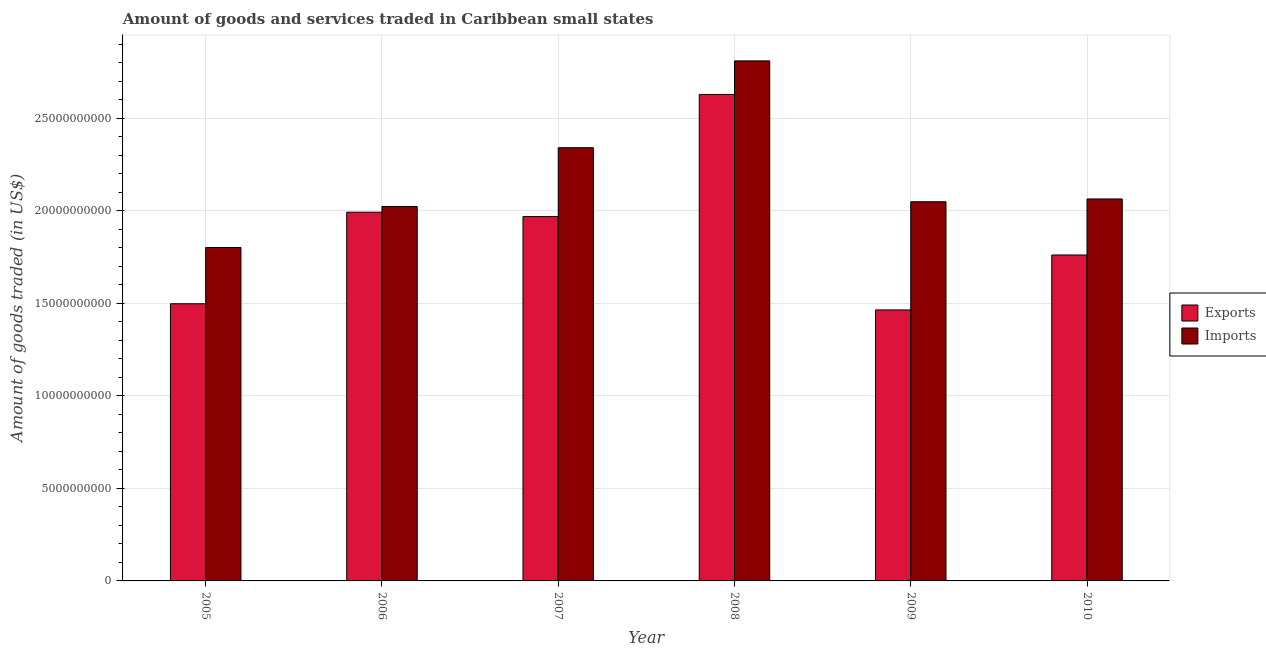How many different coloured bars are there?
Offer a terse response. 2. How many groups of bars are there?
Keep it short and to the point. 6. Are the number of bars per tick equal to the number of legend labels?
Make the answer very short. Yes. How many bars are there on the 4th tick from the left?
Offer a terse response. 2. How many bars are there on the 2nd tick from the right?
Give a very brief answer. 2. What is the label of the 1st group of bars from the left?
Ensure brevity in your answer.  2005. What is the amount of goods imported in 2005?
Your answer should be very brief. 1.80e+1. Across all years, what is the maximum amount of goods imported?
Give a very brief answer. 2.81e+1. Across all years, what is the minimum amount of goods imported?
Your answer should be compact. 1.80e+1. In which year was the amount of goods exported minimum?
Provide a succinct answer. 2009. What is the total amount of goods exported in the graph?
Your answer should be very brief. 1.13e+11. What is the difference between the amount of goods exported in 2009 and that in 2010?
Ensure brevity in your answer.  -2.97e+09. What is the difference between the amount of goods imported in 2005 and the amount of goods exported in 2006?
Keep it short and to the point. -2.21e+09. What is the average amount of goods exported per year?
Provide a succinct answer. 1.89e+1. What is the ratio of the amount of goods imported in 2006 to that in 2007?
Give a very brief answer. 0.86. What is the difference between the highest and the second highest amount of goods imported?
Make the answer very short. 4.69e+09. What is the difference between the highest and the lowest amount of goods exported?
Your answer should be very brief. 1.16e+1. What does the 2nd bar from the left in 2009 represents?
Offer a terse response. Imports. What does the 2nd bar from the right in 2007 represents?
Give a very brief answer. Exports. Are all the bars in the graph horizontal?
Provide a succinct answer. No. How many years are there in the graph?
Give a very brief answer. 6. What is the difference between two consecutive major ticks on the Y-axis?
Provide a succinct answer. 5.00e+09. Does the graph contain any zero values?
Provide a short and direct response. No. Where does the legend appear in the graph?
Your response must be concise. Center right. How many legend labels are there?
Provide a succinct answer. 2. How are the legend labels stacked?
Give a very brief answer. Vertical. What is the title of the graph?
Ensure brevity in your answer.  Amount of goods and services traded in Caribbean small states. What is the label or title of the Y-axis?
Provide a short and direct response. Amount of goods traded (in US$). What is the Amount of goods traded (in US$) in Exports in 2005?
Give a very brief answer. 1.50e+1. What is the Amount of goods traded (in US$) of Imports in 2005?
Offer a very short reply. 1.80e+1. What is the Amount of goods traded (in US$) of Exports in 2006?
Offer a very short reply. 1.99e+1. What is the Amount of goods traded (in US$) in Imports in 2006?
Offer a very short reply. 2.02e+1. What is the Amount of goods traded (in US$) in Exports in 2007?
Provide a short and direct response. 1.97e+1. What is the Amount of goods traded (in US$) of Imports in 2007?
Offer a very short reply. 2.34e+1. What is the Amount of goods traded (in US$) of Exports in 2008?
Keep it short and to the point. 2.63e+1. What is the Amount of goods traded (in US$) of Imports in 2008?
Give a very brief answer. 2.81e+1. What is the Amount of goods traded (in US$) in Exports in 2009?
Ensure brevity in your answer.  1.46e+1. What is the Amount of goods traded (in US$) of Imports in 2009?
Provide a short and direct response. 2.05e+1. What is the Amount of goods traded (in US$) in Exports in 2010?
Your answer should be compact. 1.76e+1. What is the Amount of goods traded (in US$) in Imports in 2010?
Provide a short and direct response. 2.06e+1. Across all years, what is the maximum Amount of goods traded (in US$) in Exports?
Provide a short and direct response. 2.63e+1. Across all years, what is the maximum Amount of goods traded (in US$) in Imports?
Give a very brief answer. 2.81e+1. Across all years, what is the minimum Amount of goods traded (in US$) in Exports?
Your response must be concise. 1.46e+1. Across all years, what is the minimum Amount of goods traded (in US$) in Imports?
Ensure brevity in your answer.  1.80e+1. What is the total Amount of goods traded (in US$) of Exports in the graph?
Provide a succinct answer. 1.13e+11. What is the total Amount of goods traded (in US$) of Imports in the graph?
Your response must be concise. 1.31e+11. What is the difference between the Amount of goods traded (in US$) of Exports in 2005 and that in 2006?
Your answer should be very brief. -4.95e+09. What is the difference between the Amount of goods traded (in US$) in Imports in 2005 and that in 2006?
Your answer should be very brief. -2.21e+09. What is the difference between the Amount of goods traded (in US$) of Exports in 2005 and that in 2007?
Keep it short and to the point. -4.71e+09. What is the difference between the Amount of goods traded (in US$) in Imports in 2005 and that in 2007?
Make the answer very short. -5.39e+09. What is the difference between the Amount of goods traded (in US$) in Exports in 2005 and that in 2008?
Offer a very short reply. -1.13e+1. What is the difference between the Amount of goods traded (in US$) in Imports in 2005 and that in 2008?
Make the answer very short. -1.01e+1. What is the difference between the Amount of goods traded (in US$) in Exports in 2005 and that in 2009?
Your answer should be very brief. 3.34e+08. What is the difference between the Amount of goods traded (in US$) of Imports in 2005 and that in 2009?
Make the answer very short. -2.47e+09. What is the difference between the Amount of goods traded (in US$) of Exports in 2005 and that in 2010?
Your answer should be compact. -2.63e+09. What is the difference between the Amount of goods traded (in US$) in Imports in 2005 and that in 2010?
Offer a very short reply. -2.62e+09. What is the difference between the Amount of goods traded (in US$) of Exports in 2006 and that in 2007?
Your answer should be compact. 2.35e+08. What is the difference between the Amount of goods traded (in US$) of Imports in 2006 and that in 2007?
Keep it short and to the point. -3.18e+09. What is the difference between the Amount of goods traded (in US$) of Exports in 2006 and that in 2008?
Make the answer very short. -6.36e+09. What is the difference between the Amount of goods traded (in US$) in Imports in 2006 and that in 2008?
Your answer should be compact. -7.87e+09. What is the difference between the Amount of goods traded (in US$) of Exports in 2006 and that in 2009?
Your answer should be very brief. 5.28e+09. What is the difference between the Amount of goods traded (in US$) of Imports in 2006 and that in 2009?
Give a very brief answer. -2.59e+08. What is the difference between the Amount of goods traded (in US$) of Exports in 2006 and that in 2010?
Provide a succinct answer. 2.31e+09. What is the difference between the Amount of goods traded (in US$) in Imports in 2006 and that in 2010?
Your answer should be very brief. -4.09e+08. What is the difference between the Amount of goods traded (in US$) of Exports in 2007 and that in 2008?
Offer a very short reply. -6.60e+09. What is the difference between the Amount of goods traded (in US$) of Imports in 2007 and that in 2008?
Your answer should be very brief. -4.69e+09. What is the difference between the Amount of goods traded (in US$) of Exports in 2007 and that in 2009?
Ensure brevity in your answer.  5.05e+09. What is the difference between the Amount of goods traded (in US$) in Imports in 2007 and that in 2009?
Provide a short and direct response. 2.92e+09. What is the difference between the Amount of goods traded (in US$) in Exports in 2007 and that in 2010?
Your answer should be compact. 2.08e+09. What is the difference between the Amount of goods traded (in US$) in Imports in 2007 and that in 2010?
Your answer should be very brief. 2.77e+09. What is the difference between the Amount of goods traded (in US$) of Exports in 2008 and that in 2009?
Provide a short and direct response. 1.16e+1. What is the difference between the Amount of goods traded (in US$) of Imports in 2008 and that in 2009?
Offer a terse response. 7.61e+09. What is the difference between the Amount of goods traded (in US$) in Exports in 2008 and that in 2010?
Keep it short and to the point. 8.67e+09. What is the difference between the Amount of goods traded (in US$) in Imports in 2008 and that in 2010?
Ensure brevity in your answer.  7.46e+09. What is the difference between the Amount of goods traded (in US$) of Exports in 2009 and that in 2010?
Your answer should be very brief. -2.97e+09. What is the difference between the Amount of goods traded (in US$) of Imports in 2009 and that in 2010?
Provide a short and direct response. -1.49e+08. What is the difference between the Amount of goods traded (in US$) in Exports in 2005 and the Amount of goods traded (in US$) in Imports in 2006?
Your answer should be very brief. -5.25e+09. What is the difference between the Amount of goods traded (in US$) of Exports in 2005 and the Amount of goods traded (in US$) of Imports in 2007?
Your response must be concise. -8.43e+09. What is the difference between the Amount of goods traded (in US$) in Exports in 2005 and the Amount of goods traded (in US$) in Imports in 2008?
Ensure brevity in your answer.  -1.31e+1. What is the difference between the Amount of goods traded (in US$) of Exports in 2005 and the Amount of goods traded (in US$) of Imports in 2009?
Give a very brief answer. -5.51e+09. What is the difference between the Amount of goods traded (in US$) in Exports in 2005 and the Amount of goods traded (in US$) in Imports in 2010?
Give a very brief answer. -5.66e+09. What is the difference between the Amount of goods traded (in US$) in Exports in 2006 and the Amount of goods traded (in US$) in Imports in 2007?
Provide a short and direct response. -3.49e+09. What is the difference between the Amount of goods traded (in US$) of Exports in 2006 and the Amount of goods traded (in US$) of Imports in 2008?
Offer a terse response. -8.18e+09. What is the difference between the Amount of goods traded (in US$) in Exports in 2006 and the Amount of goods traded (in US$) in Imports in 2009?
Offer a terse response. -5.67e+08. What is the difference between the Amount of goods traded (in US$) in Exports in 2006 and the Amount of goods traded (in US$) in Imports in 2010?
Offer a terse response. -7.16e+08. What is the difference between the Amount of goods traded (in US$) of Exports in 2007 and the Amount of goods traded (in US$) of Imports in 2008?
Provide a succinct answer. -8.41e+09. What is the difference between the Amount of goods traded (in US$) of Exports in 2007 and the Amount of goods traded (in US$) of Imports in 2009?
Your answer should be very brief. -8.01e+08. What is the difference between the Amount of goods traded (in US$) in Exports in 2007 and the Amount of goods traded (in US$) in Imports in 2010?
Your answer should be very brief. -9.51e+08. What is the difference between the Amount of goods traded (in US$) in Exports in 2008 and the Amount of goods traded (in US$) in Imports in 2009?
Provide a short and direct response. 5.79e+09. What is the difference between the Amount of goods traded (in US$) in Exports in 2008 and the Amount of goods traded (in US$) in Imports in 2010?
Make the answer very short. 5.65e+09. What is the difference between the Amount of goods traded (in US$) of Exports in 2009 and the Amount of goods traded (in US$) of Imports in 2010?
Provide a succinct answer. -6.00e+09. What is the average Amount of goods traded (in US$) of Exports per year?
Your response must be concise. 1.89e+1. What is the average Amount of goods traded (in US$) of Imports per year?
Your response must be concise. 2.18e+1. In the year 2005, what is the difference between the Amount of goods traded (in US$) in Exports and Amount of goods traded (in US$) in Imports?
Give a very brief answer. -3.04e+09. In the year 2006, what is the difference between the Amount of goods traded (in US$) of Exports and Amount of goods traded (in US$) of Imports?
Keep it short and to the point. -3.07e+08. In the year 2007, what is the difference between the Amount of goods traded (in US$) of Exports and Amount of goods traded (in US$) of Imports?
Provide a succinct answer. -3.72e+09. In the year 2008, what is the difference between the Amount of goods traded (in US$) in Exports and Amount of goods traded (in US$) in Imports?
Provide a succinct answer. -1.81e+09. In the year 2009, what is the difference between the Amount of goods traded (in US$) of Exports and Amount of goods traded (in US$) of Imports?
Offer a very short reply. -5.85e+09. In the year 2010, what is the difference between the Amount of goods traded (in US$) in Exports and Amount of goods traded (in US$) in Imports?
Your answer should be very brief. -3.03e+09. What is the ratio of the Amount of goods traded (in US$) in Exports in 2005 to that in 2006?
Provide a short and direct response. 0.75. What is the ratio of the Amount of goods traded (in US$) in Imports in 2005 to that in 2006?
Make the answer very short. 0.89. What is the ratio of the Amount of goods traded (in US$) of Exports in 2005 to that in 2007?
Provide a short and direct response. 0.76. What is the ratio of the Amount of goods traded (in US$) of Imports in 2005 to that in 2007?
Your answer should be compact. 0.77. What is the ratio of the Amount of goods traded (in US$) in Exports in 2005 to that in 2008?
Provide a short and direct response. 0.57. What is the ratio of the Amount of goods traded (in US$) in Imports in 2005 to that in 2008?
Offer a very short reply. 0.64. What is the ratio of the Amount of goods traded (in US$) of Exports in 2005 to that in 2009?
Offer a very short reply. 1.02. What is the ratio of the Amount of goods traded (in US$) in Imports in 2005 to that in 2009?
Provide a short and direct response. 0.88. What is the ratio of the Amount of goods traded (in US$) in Exports in 2005 to that in 2010?
Your response must be concise. 0.85. What is the ratio of the Amount of goods traded (in US$) of Imports in 2005 to that in 2010?
Provide a short and direct response. 0.87. What is the ratio of the Amount of goods traded (in US$) of Exports in 2006 to that in 2007?
Your response must be concise. 1.01. What is the ratio of the Amount of goods traded (in US$) in Imports in 2006 to that in 2007?
Your answer should be compact. 0.86. What is the ratio of the Amount of goods traded (in US$) in Exports in 2006 to that in 2008?
Your answer should be compact. 0.76. What is the ratio of the Amount of goods traded (in US$) of Imports in 2006 to that in 2008?
Keep it short and to the point. 0.72. What is the ratio of the Amount of goods traded (in US$) in Exports in 2006 to that in 2009?
Provide a short and direct response. 1.36. What is the ratio of the Amount of goods traded (in US$) of Imports in 2006 to that in 2009?
Keep it short and to the point. 0.99. What is the ratio of the Amount of goods traded (in US$) in Exports in 2006 to that in 2010?
Your answer should be very brief. 1.13. What is the ratio of the Amount of goods traded (in US$) of Imports in 2006 to that in 2010?
Ensure brevity in your answer.  0.98. What is the ratio of the Amount of goods traded (in US$) in Exports in 2007 to that in 2008?
Keep it short and to the point. 0.75. What is the ratio of the Amount of goods traded (in US$) of Imports in 2007 to that in 2008?
Your answer should be very brief. 0.83. What is the ratio of the Amount of goods traded (in US$) of Exports in 2007 to that in 2009?
Offer a very short reply. 1.34. What is the ratio of the Amount of goods traded (in US$) of Imports in 2007 to that in 2009?
Make the answer very short. 1.14. What is the ratio of the Amount of goods traded (in US$) of Exports in 2007 to that in 2010?
Offer a very short reply. 1.12. What is the ratio of the Amount of goods traded (in US$) in Imports in 2007 to that in 2010?
Your response must be concise. 1.13. What is the ratio of the Amount of goods traded (in US$) of Exports in 2008 to that in 2009?
Keep it short and to the point. 1.8. What is the ratio of the Amount of goods traded (in US$) of Imports in 2008 to that in 2009?
Keep it short and to the point. 1.37. What is the ratio of the Amount of goods traded (in US$) in Exports in 2008 to that in 2010?
Give a very brief answer. 1.49. What is the ratio of the Amount of goods traded (in US$) in Imports in 2008 to that in 2010?
Your response must be concise. 1.36. What is the ratio of the Amount of goods traded (in US$) of Exports in 2009 to that in 2010?
Offer a very short reply. 0.83. What is the ratio of the Amount of goods traded (in US$) in Imports in 2009 to that in 2010?
Make the answer very short. 0.99. What is the difference between the highest and the second highest Amount of goods traded (in US$) in Exports?
Offer a terse response. 6.36e+09. What is the difference between the highest and the second highest Amount of goods traded (in US$) of Imports?
Make the answer very short. 4.69e+09. What is the difference between the highest and the lowest Amount of goods traded (in US$) of Exports?
Provide a succinct answer. 1.16e+1. What is the difference between the highest and the lowest Amount of goods traded (in US$) of Imports?
Keep it short and to the point. 1.01e+1. 